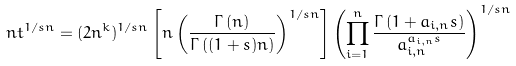Convert formula to latex. <formula><loc_0><loc_0><loc_500><loc_500>n t ^ { 1 / s n } = ( 2 n ^ { k } ) ^ { 1 / s n } \left [ n \left ( \frac { \Gamma \left ( n \right ) } { \Gamma \left ( ( 1 + s ) n \right ) } \right ) ^ { 1 / s n } \right ] \left ( \prod _ { i = 1 } ^ { n } \frac { \Gamma \left ( 1 + a _ { i , n } s \right ) } { a _ { i , n } ^ { a _ { i , n } s } } \right ) ^ { 1 / s n }</formula> 